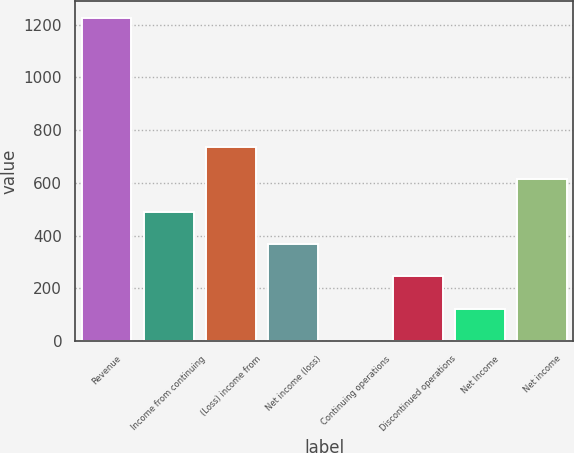<chart> <loc_0><loc_0><loc_500><loc_500><bar_chart><fcel>Revenue<fcel>Income from continuing<fcel>(Loss) income from<fcel>Net income (loss)<fcel>Continuing operations<fcel>Discontinued operations<fcel>Net Income<fcel>Net income<nl><fcel>1226<fcel>490.8<fcel>735.86<fcel>368.27<fcel>0.68<fcel>245.74<fcel>123.21<fcel>613.33<nl></chart> 